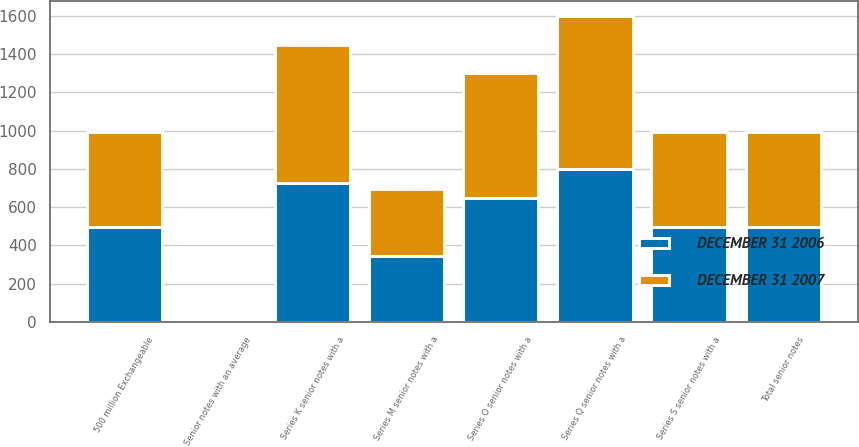Convert chart to OTSL. <chart><loc_0><loc_0><loc_500><loc_500><stacked_bar_chart><ecel><fcel>Series K senior notes with a<fcel>Series M senior notes with a<fcel>Series O senior notes with a<fcel>Series Q senior notes with a<fcel>Series S senior notes with a<fcel>500 million Exchangeable<fcel>Senior notes with an average<fcel>Total senior notes<nl><fcel>DECEMBER 31 2007<fcel>725<fcel>347<fcel>650<fcel>800<fcel>497<fcel>496<fcel>7<fcel>496.5<nl><fcel>DECEMBER 31 2006<fcel>725<fcel>347<fcel>650<fcel>800<fcel>496<fcel>495<fcel>13<fcel>496.5<nl></chart> 